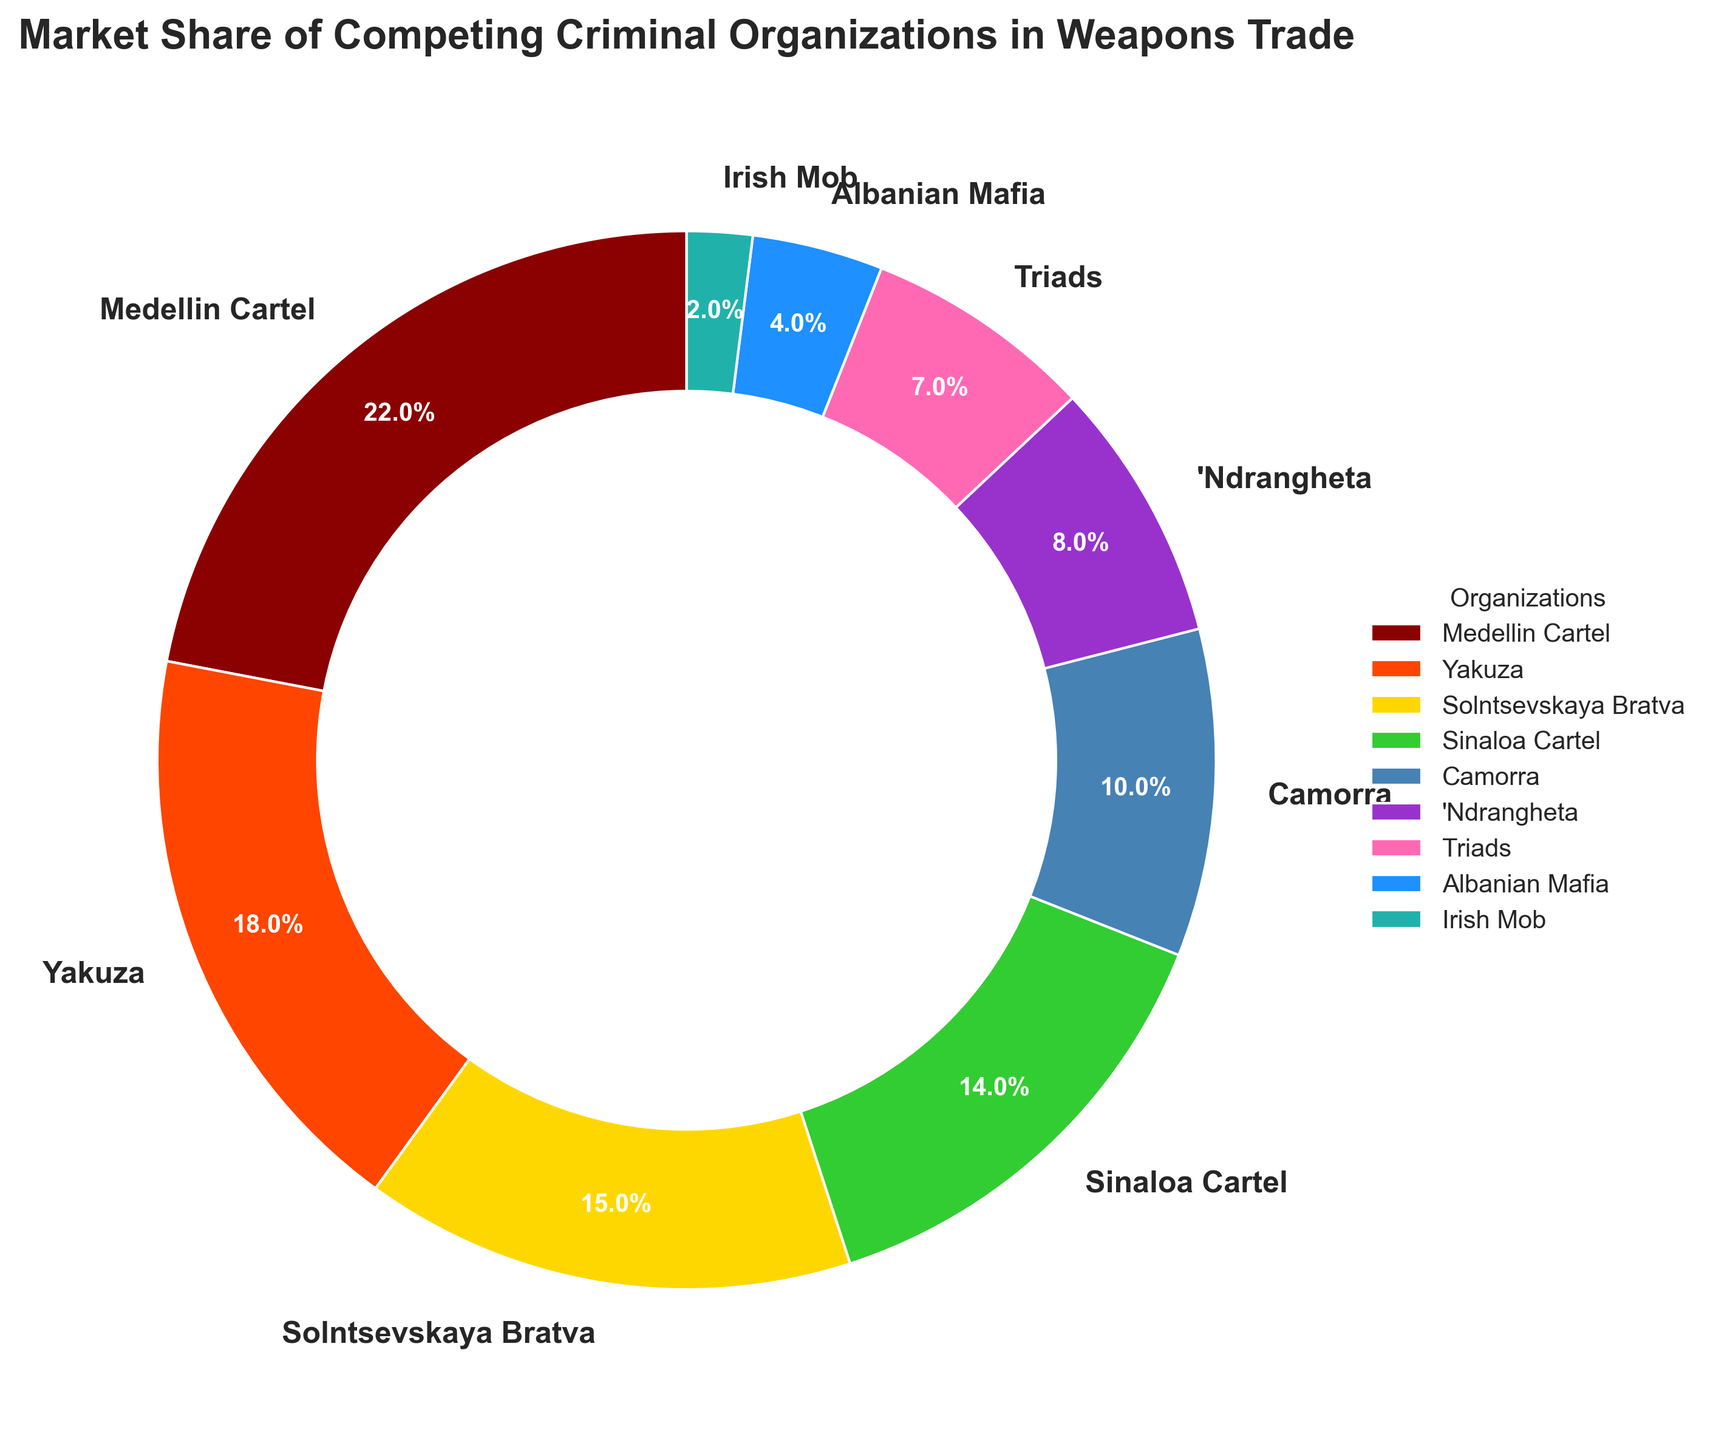What percentage of the weapon trade market is controlled by the top three organizations? To find this, look at the market share percentages of the top three organizations: Medellin Cartel (22%), Yakuza (18%), and Solntsevskaya Bratva (15%). Add these percentages together: 22 + 18 + 15 = 55%.
Answer: 55% What is the difference in market share between the Medellin Cartel and the Yakuza? The Medellin Cartel controls 22% of the market, while the Yakuza controls 18%. Subtract the Yakuza's market share from the Medellin Cartel's: 22 - 18 = 4%.
Answer: 4% Which organization has the smallest market share? The Irish Mob has the smallest market share in the pie chart, which is 2%.
Answer: Irish Mob Compare the combined market share of the Solntsevskaya Bratva and the Sinaloa Cartel to the Medellin Cartel. The Solntsevskaya Bratva has 15% and the Sinaloa Cartel has 14%, totaling 15 + 14 = 29%. The Medellin Cartel has 22%. Comparing these, 29% > 22%.
Answer: Solntsevskaya Bratva and Sinaloa Cartel combined What percentage of the market is controlled by organizations with less than 10% share each? Organizations with less than 10% share are the 'Ndrangheta (8%), Triads (7%), Albanian Mafia (4%), and Irish Mob (2%). Add their percentages: 8 + 7 + 4 + 2 = 21%.
Answer: 21% How much larger is the market share of the Sinaloa Cartel compared to the Camorra? The Sinaloa Cartel has 14% market share, and the Camorra has 10%. Subtract the Camorra's share from the Sinaloa Cartel's: 14 - 10 = 4%.
Answer: 4% What is the total market share of all organizations? The total market share of all the segments in the pie chart must add up to 100%.
Answer: 100% Between the Triads and the Albanian Mafia, which organization has a larger market share? The Triads have a 7% market share, while the Albanian Mafia has 4%. Comparing these, 7% > 4%.
Answer: Triads Does the combined market share of the Yakuza and Solntsevskaya Bratva exceed 30%? The Yakuza has 18% and the Solntsevskaya Bratva has 15%. Add these figures together: 18 + 15 = 33%, which is greater than 30%.
Answer: Yes 